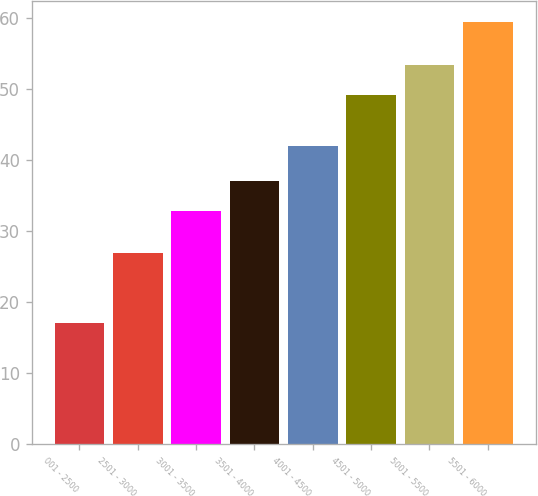Convert chart. <chart><loc_0><loc_0><loc_500><loc_500><bar_chart><fcel>001 - 2500<fcel>2501 - 3000<fcel>3001 - 3500<fcel>3501 - 4000<fcel>4001 - 4500<fcel>4501 - 5000<fcel>5001 - 5500<fcel>5501 - 6000<nl><fcel>17.04<fcel>26.92<fcel>32.73<fcel>36.97<fcel>41.88<fcel>49.15<fcel>53.39<fcel>59.42<nl></chart> 